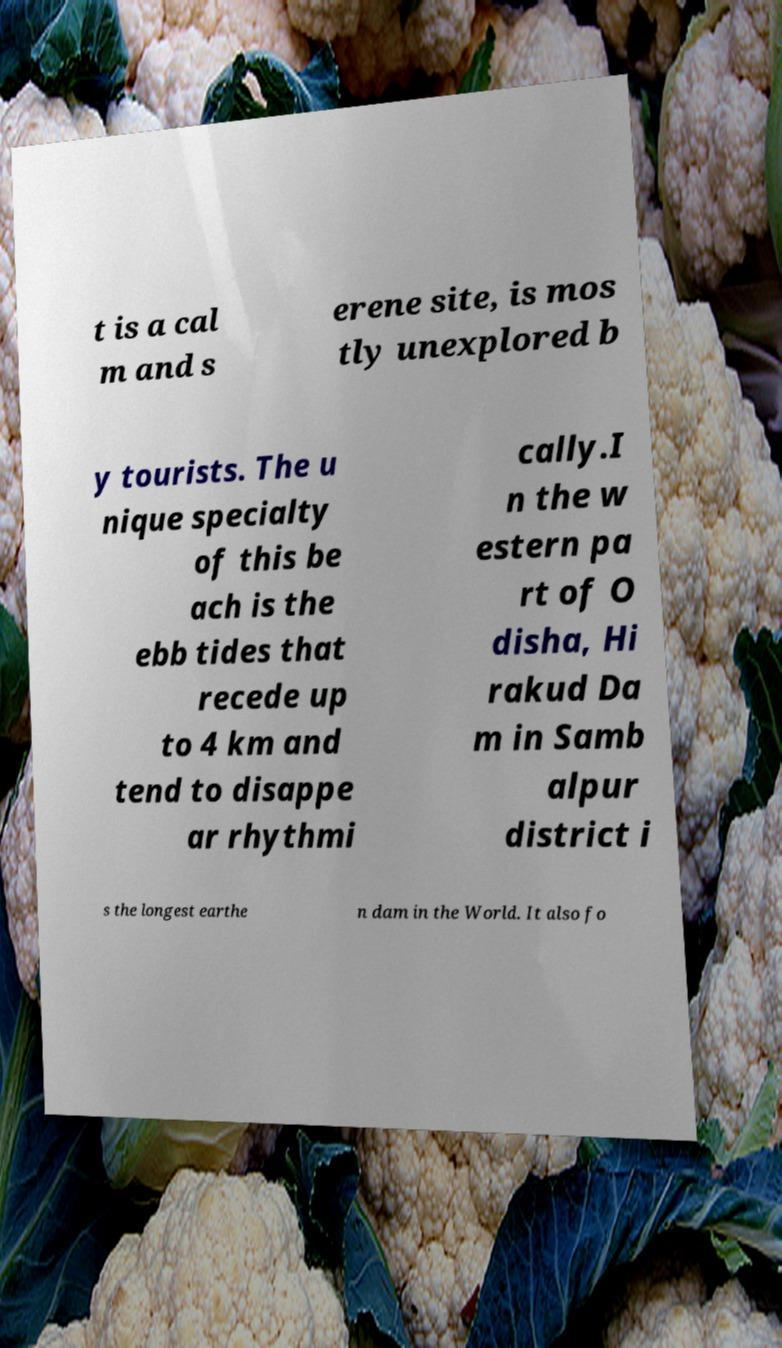Please read and relay the text visible in this image. What does it say? t is a cal m and s erene site, is mos tly unexplored b y tourists. The u nique specialty of this be ach is the ebb tides that recede up to 4 km and tend to disappe ar rhythmi cally.I n the w estern pa rt of O disha, Hi rakud Da m in Samb alpur district i s the longest earthe n dam in the World. It also fo 